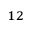<formula> <loc_0><loc_0><loc_500><loc_500>^ { 1 2 }</formula> 